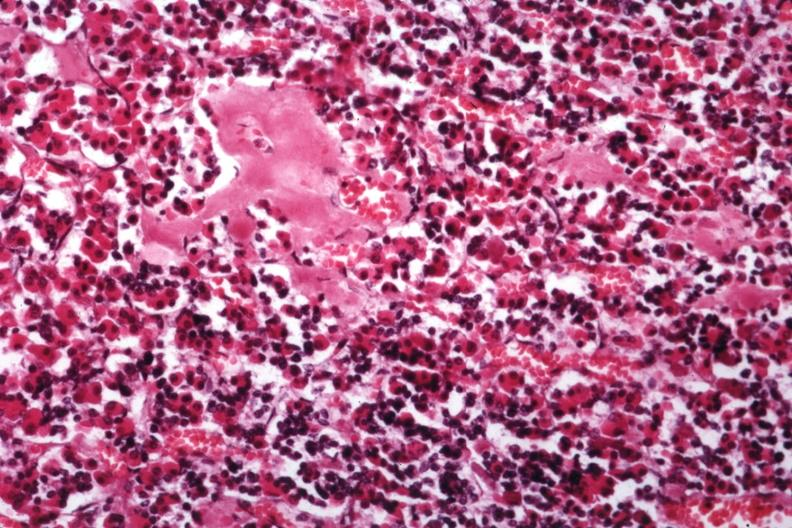re there several slides from this case in this file 23 yowf amyloid limited to brain?
Answer the question using a single word or phrase. Yes 